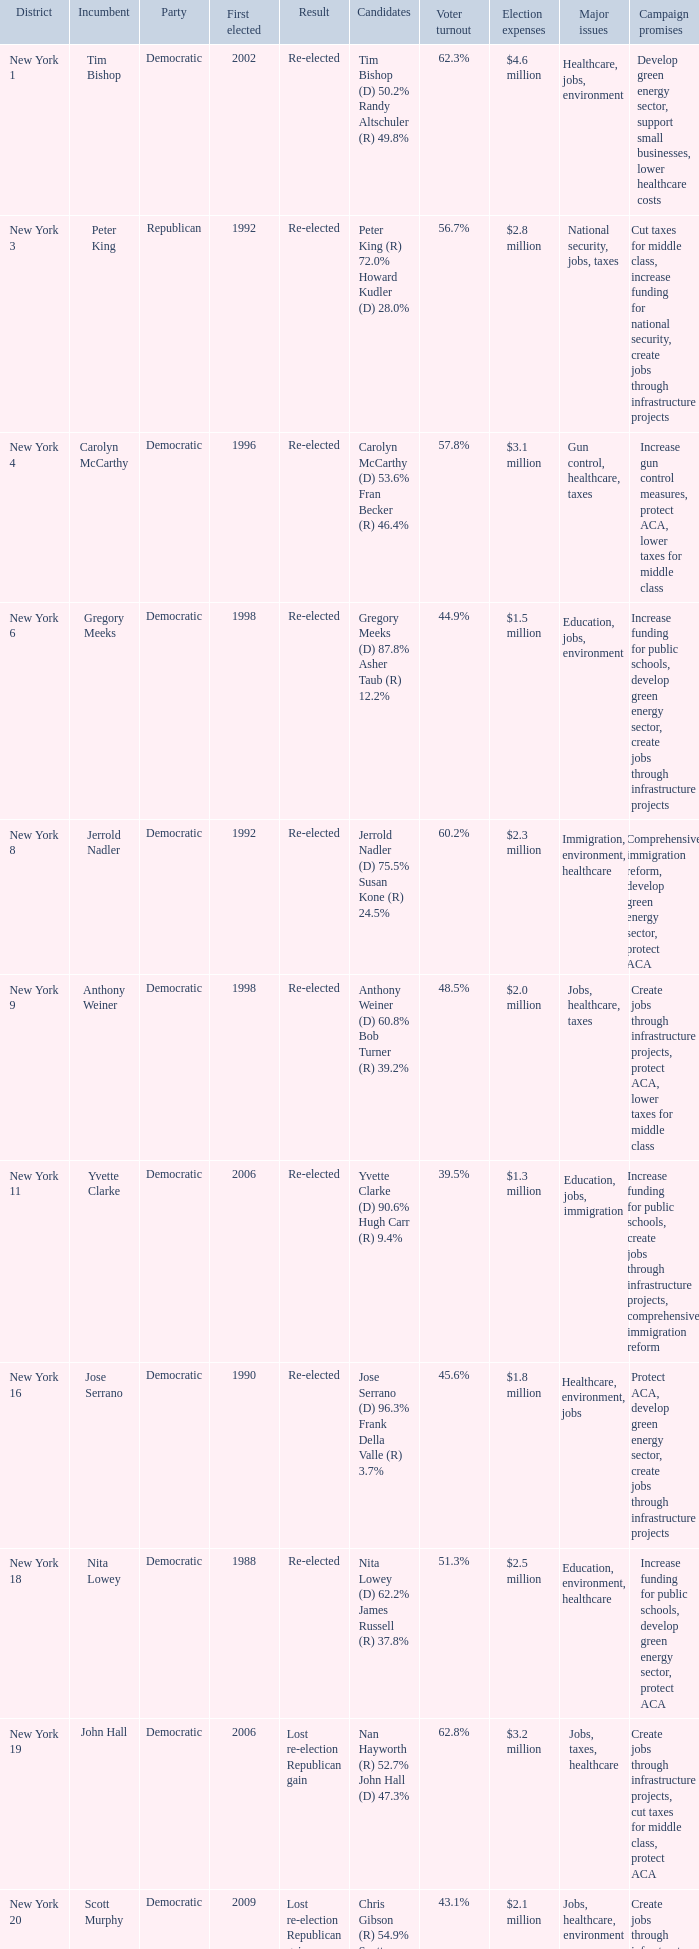Name the party for yvette clarke (d) 90.6% hugh carr (r) 9.4% Democratic. 